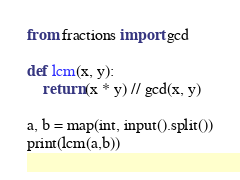<code> <loc_0><loc_0><loc_500><loc_500><_Python_>from fractions import gcd

def lcm(x, y):
    return (x * y) // gcd(x, y)

a, b = map(int, input().split())
print(lcm(a,b))</code> 